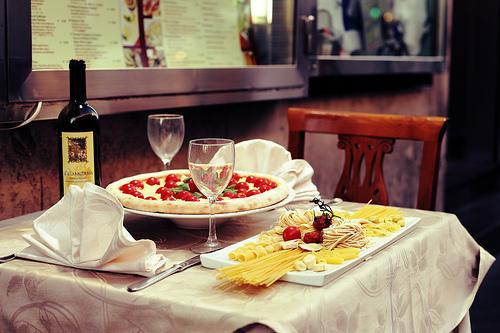Enumerate four prominent elements present in the image. Dry pasta on a plate, a folded white napkin, a dark wine bottle with a yellow label, and empty wine glasses occupy the table. Describe the scene's ambiance through the use of a metaphor. The table, adorned with elegantly folded napkins, resembles a stage set for a grand performance of culinary delights. Explain the seating arrangement in the image. A wooden chair sits near the table, its back visible, providing the perfect resting place for an awaiting diner. Write a brief overview of the table setup, using an elegant style. An exquisite dinner table awaits, with uncooked pasta masterfully plated, empty wine glasses positioned near each setting, and white linen napkins folded like seashells. Describe the table setting in a poetic way. Amidst folded napkins and gleaming silverware, an inviting feast welcomes guests, with wine glasses waiting to be filled. Describe the image using a cheerful tone. A delightful dinner scene is set, with colorfully topped pasta and pizza, empty wine glasses ready to be filled, and beautifully folded napkins welcoming guests. Mention the presence of a specific type of element on the table. On the table, a dark wine bottle with a yellow label silently tempts the palate, standing tall between two empty wine glasses. Using a futuristic tone, explain what can be seen on the dining table. In a world where humans still gather, a fully set table displays a variety of pastas and a whole pizza, surrounded by empty wine glasses. Write a brief description of the main dish presented on the table. Dry pasta is served on a long white rectangular plate, topped with meatballs and delicious cherry tomatoes. Using a nostalgic tone, describe the main elements of the image. A fully set table reminds us of times when loved ones gathered, sharing pizzas, pasta, and warm conversation over glasses of wine. 